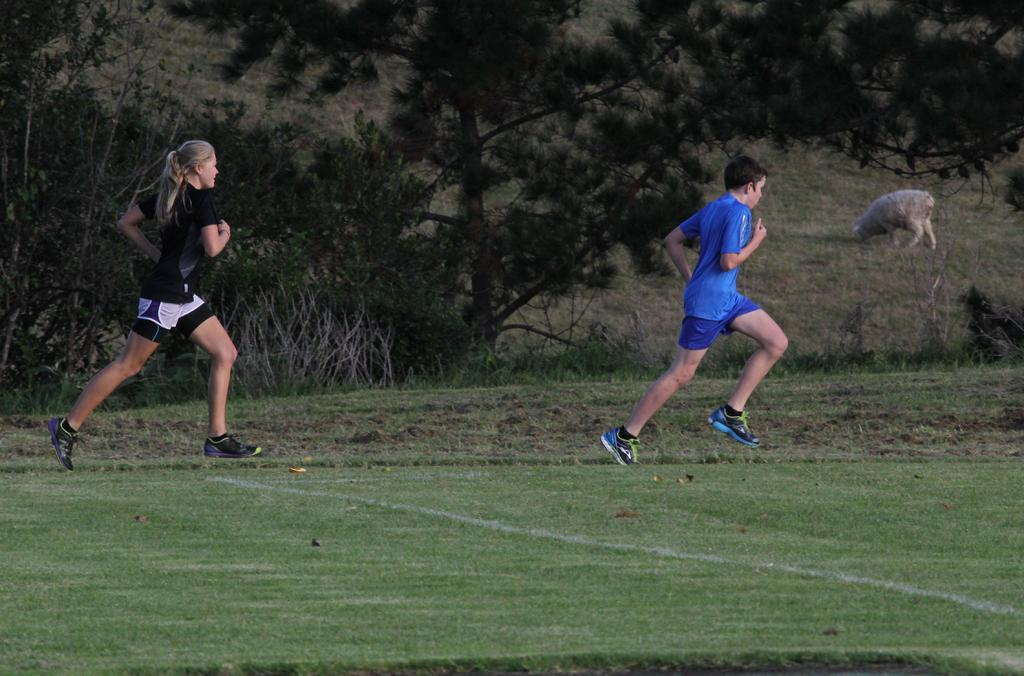What are the two people in the image doing? The two people in the image are running. On what surface are the people running? The people are running on the ground. What can be seen in the background of the image? There are trees and plants in the background of the image. Is there any wildlife visible in the image? Yes, there is an animal grazing the grass in the background of the image. How many pizzas are being delivered by the train in the image? There is no train or pizzas present in the image. What is the size of the animal grazing the grass in the image? The size of the animal grazing the grass cannot be determined from the image alone, as there is no reference point for comparison. 